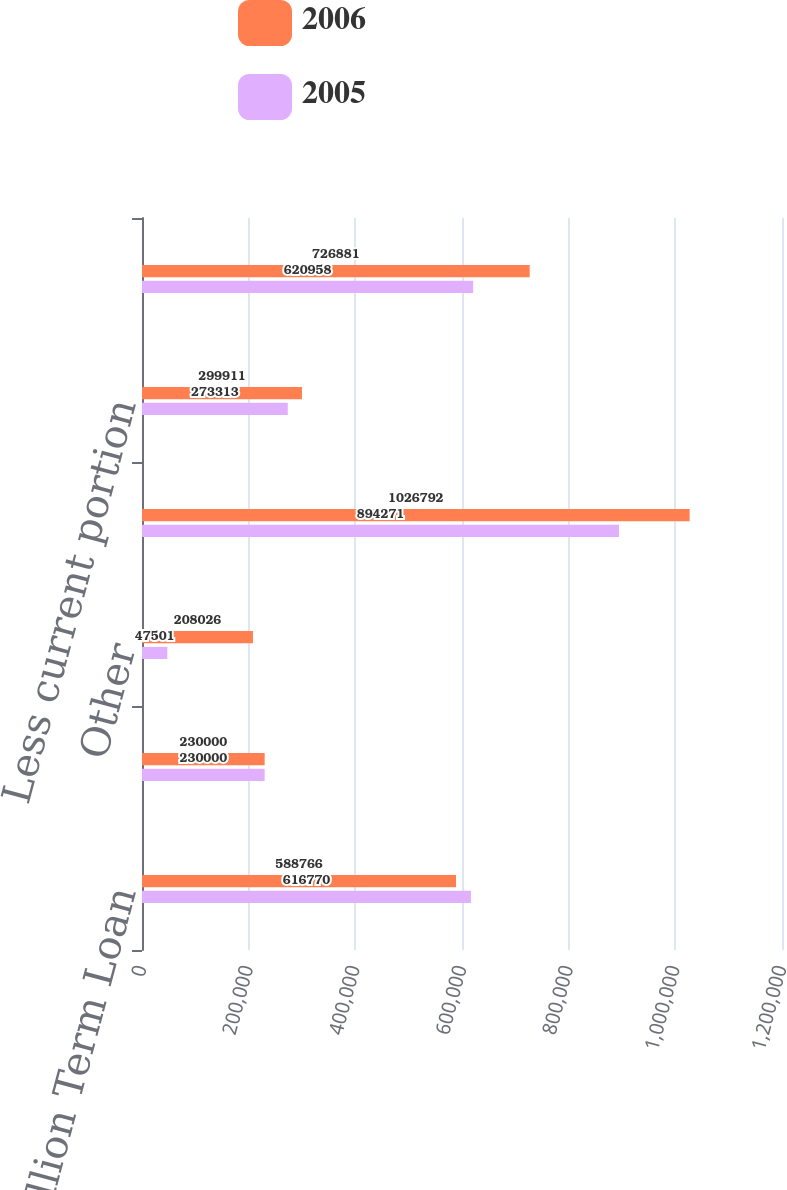Convert chart. <chart><loc_0><loc_0><loc_500><loc_500><stacked_bar_chart><ecel><fcel>655 million Term Loan<fcel>Senior Subordinated<fcel>Other<fcel>Total debt<fcel>Less current portion<fcel>Long-term debt<nl><fcel>2006<fcel>588766<fcel>230000<fcel>208026<fcel>1.02679e+06<fcel>299911<fcel>726881<nl><fcel>2005<fcel>616770<fcel>230000<fcel>47501<fcel>894271<fcel>273313<fcel>620958<nl></chart> 